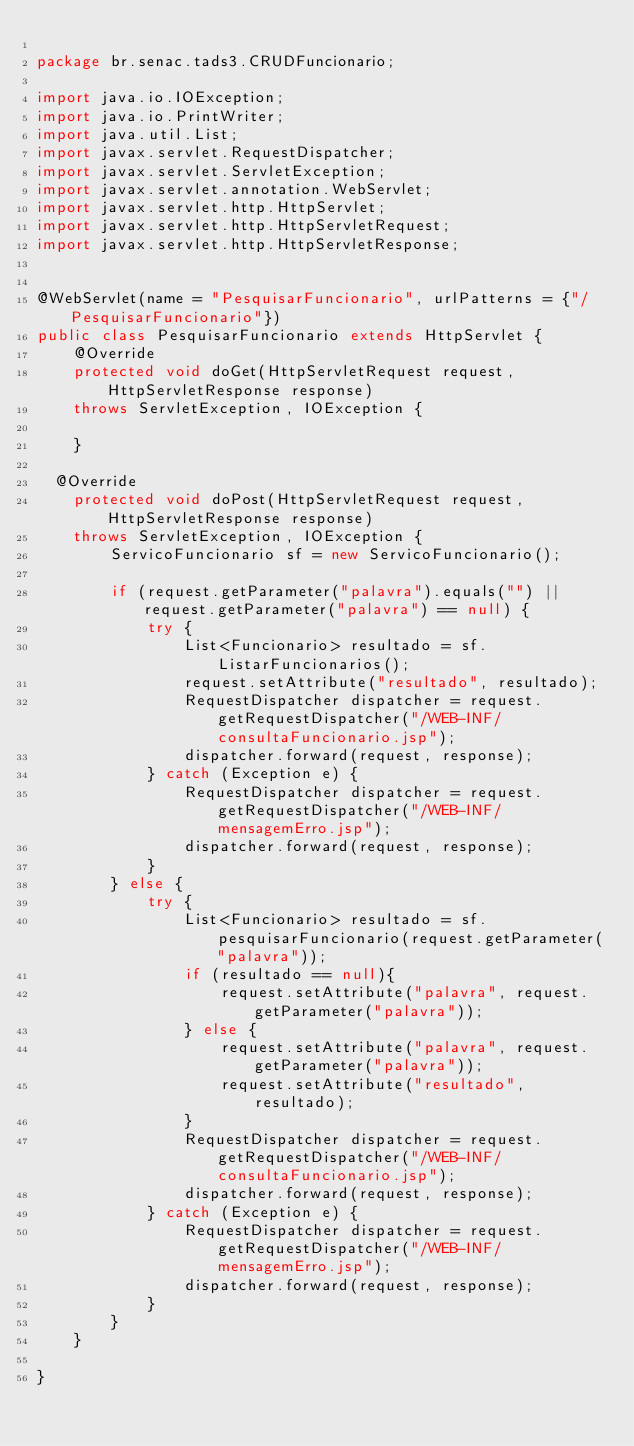Convert code to text. <code><loc_0><loc_0><loc_500><loc_500><_Java_>
package br.senac.tads3.CRUDFuncionario;

import java.io.IOException;
import java.io.PrintWriter;
import java.util.List;
import javax.servlet.RequestDispatcher;
import javax.servlet.ServletException;
import javax.servlet.annotation.WebServlet;
import javax.servlet.http.HttpServlet;
import javax.servlet.http.HttpServletRequest;
import javax.servlet.http.HttpServletResponse;


@WebServlet(name = "PesquisarFuncionario", urlPatterns = {"/PesquisarFuncionario"})
public class PesquisarFuncionario extends HttpServlet {
    @Override
    protected void doGet(HttpServletRequest request, HttpServletResponse response)
	  throws ServletException, IOException {
        
    }

  @Override
    protected void doPost(HttpServletRequest request, HttpServletResponse response)
	  throws ServletException, IOException {
        ServicoFuncionario sf = new ServicoFuncionario();
        
        if (request.getParameter("palavra").equals("") || request.getParameter("palavra") == null) {
            try {
                List<Funcionario> resultado = sf.ListarFuncionarios();
                request.setAttribute("resultado", resultado);
                RequestDispatcher dispatcher = request.getRequestDispatcher("/WEB-INF/consultaFuncionario.jsp");
                dispatcher.forward(request, response);
            } catch (Exception e) {
                RequestDispatcher dispatcher = request.getRequestDispatcher("/WEB-INF/mensagemErro.jsp");
                dispatcher.forward(request, response);
            }
        } else {
            try {
                List<Funcionario> resultado = sf.pesquisarFuncionario(request.getParameter("palavra"));
                if (resultado == null){
                    request.setAttribute("palavra", request.getParameter("palavra"));
                } else {
                    request.setAttribute("palavra", request.getParameter("palavra"));
                    request.setAttribute("resultado", resultado);
                }
                RequestDispatcher dispatcher = request.getRequestDispatcher("/WEB-INF/consultaFuncionario.jsp");
                dispatcher.forward(request, response);
            } catch (Exception e) {
                RequestDispatcher dispatcher = request.getRequestDispatcher("/WEB-INF/mensagemErro.jsp");
                dispatcher.forward(request, response);
            }
        }
    }
    
}


</code> 